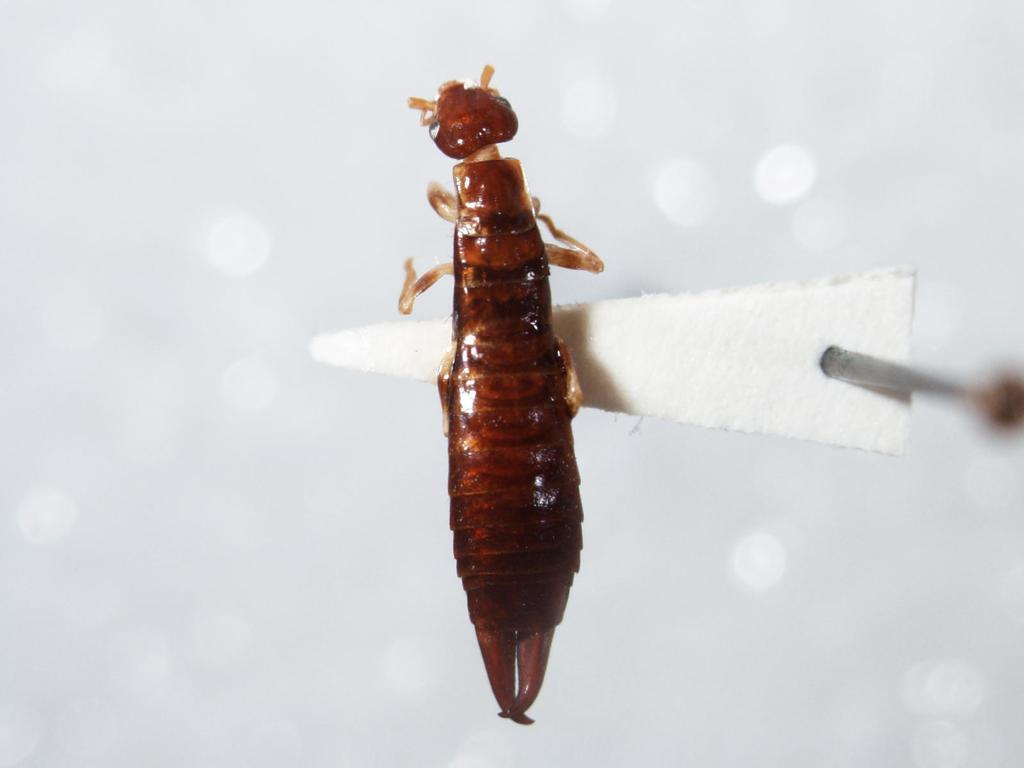What type of creature is present in the image? There is an insect in the image. What is the insect resting on? The insect is on a white object. Can you describe the background of the image? The background of the image is blurred. What type of engine can be seen in the image? There is no engine present in the image; it features an insect on a white object with a blurred background. 